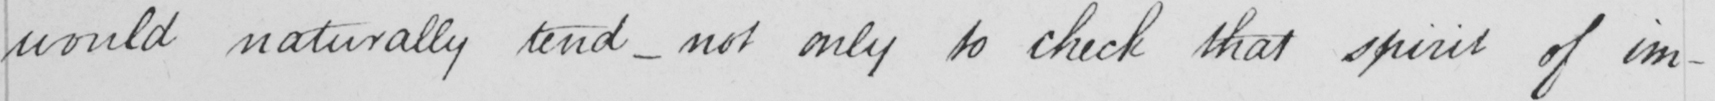Please transcribe the handwritten text in this image. would naturally tend  _  not only to check that spirit of im- 